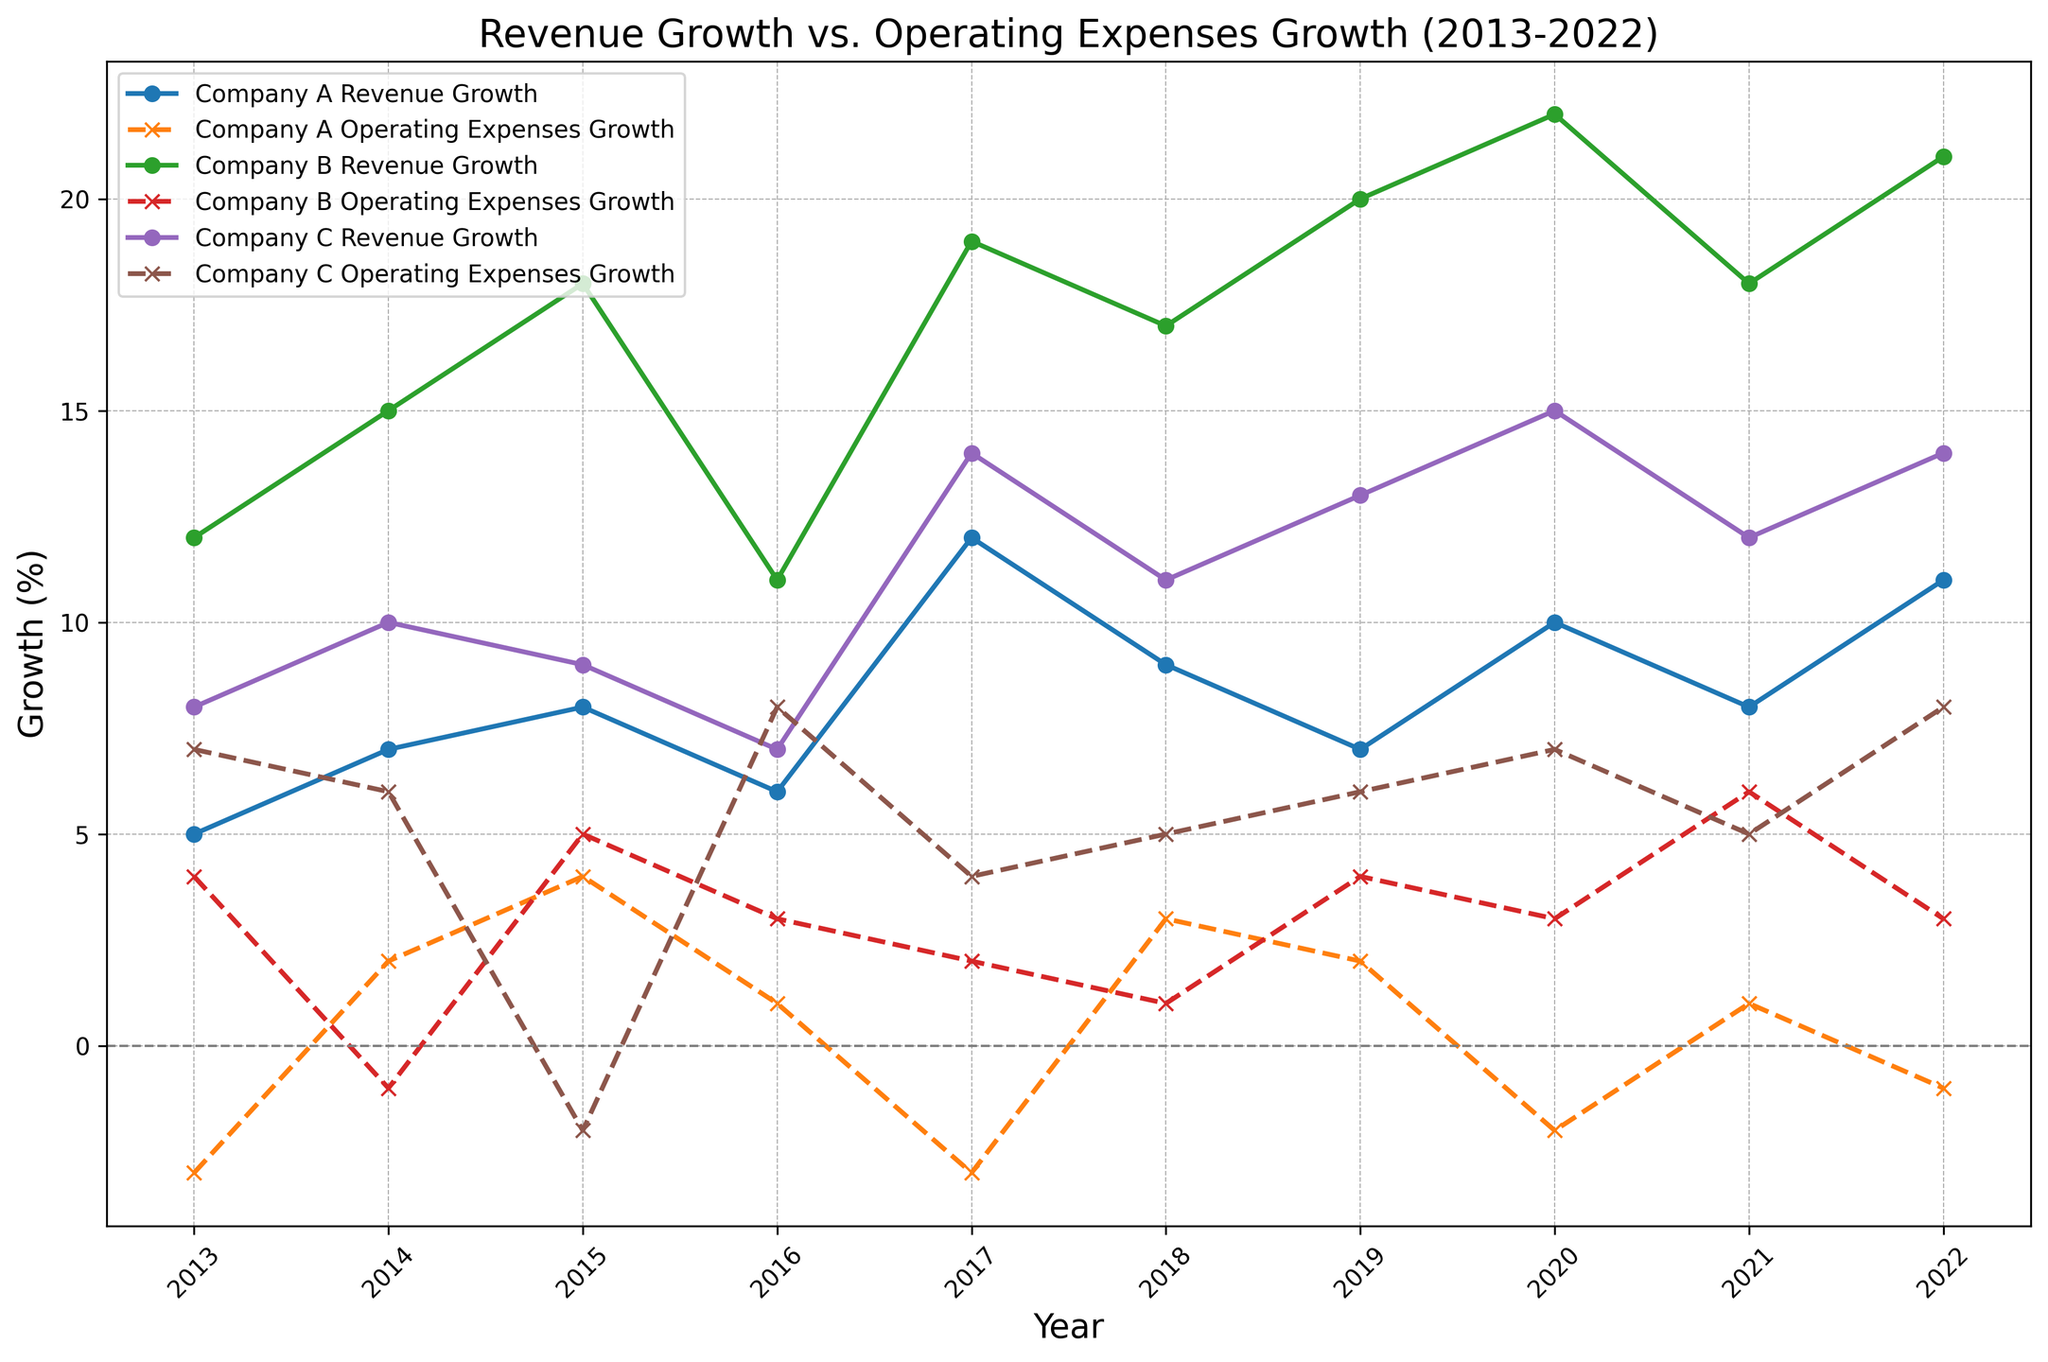What year did Company B experience the highest revenue growth? To determine the year of the highest revenue growth for Company B, observe the plotted line representing Company B’s revenue growth and identify the year corresponding to the highest point on the chart.
Answer: 2020 Did any company experience negative operating expenses growth in 2015? Check the points on the line corresponding to operating expenses growth for the year 2015 for each company. Company C's operating expenses growth is shown to be -2% in 2015.
Answer: Yes, Company C Compare the revenue growth trend of Company A and Company C between 2013 and 2017. Which company shows more consistent growth? Observe the revenue growth lines for Company A and Company C between 2013 and 2017. Company A’s growth fluctuates but stays within a tighter range compared to Company C. Company C has more variation in this period.
Answer: Company A How did the operating expenses growth of Company A change from 2017 to 2018? Look at the position of the markers for Company A’s operating expenses growth at 2017 and 2018. The chart indicates a shift from -3% in 2017 to 3% in 2018.
Answer: Increased by 6% Which company had the lowest revenue growth in 2022? Locate the points on the revenue growth lines for each company corresponding to the year 2022. Company A has the lowest point at 11%.
Answer: Company A In which year did Company B and Company C have equal operating expenses growth? Compare the operating expenses growth lines for Company B and Company C to identify the year where they intersect. Both companies had an operating expenses growth of 3% in 2022.
Answer: 2022 Is there any year where Company A had a negative operating expenses growth while its revenue growth was positive? Look for years where Company A’s revenue growth line is above 0% and its operating expenses growth line is below 0%. This occurs in 2013, 2017, and 2020.
Answer: Yes, 2013, 2017, 2020 What is the average revenue growth of Company C from 2013 to 2022? Sum the revenue growth values for Company C from 2013 to 2022 and divide by the number of years (10). The values are 8+10+9+7+14+11+13+15+12+14 = 113. Average = 113/10.
Answer: 11.3 Which company shows the steadiest increase in revenue growth over the years? Evaluate the trend lines of revenue growth for each company over the years. Company B shows a relatively steady and continuous increase in revenue growth from 2013 to 2020.
Answer: Company B Compare the maximum values of revenue growth for Company A and Company B. Which company had the higher maximum value and what was it? Identify the highest points on the revenue growth lines for Company A and Company B. Company A's highest revenue growth is 12% in 2017, while Company B's highest is 22% in 2020.
Answer: Company B, 22% 